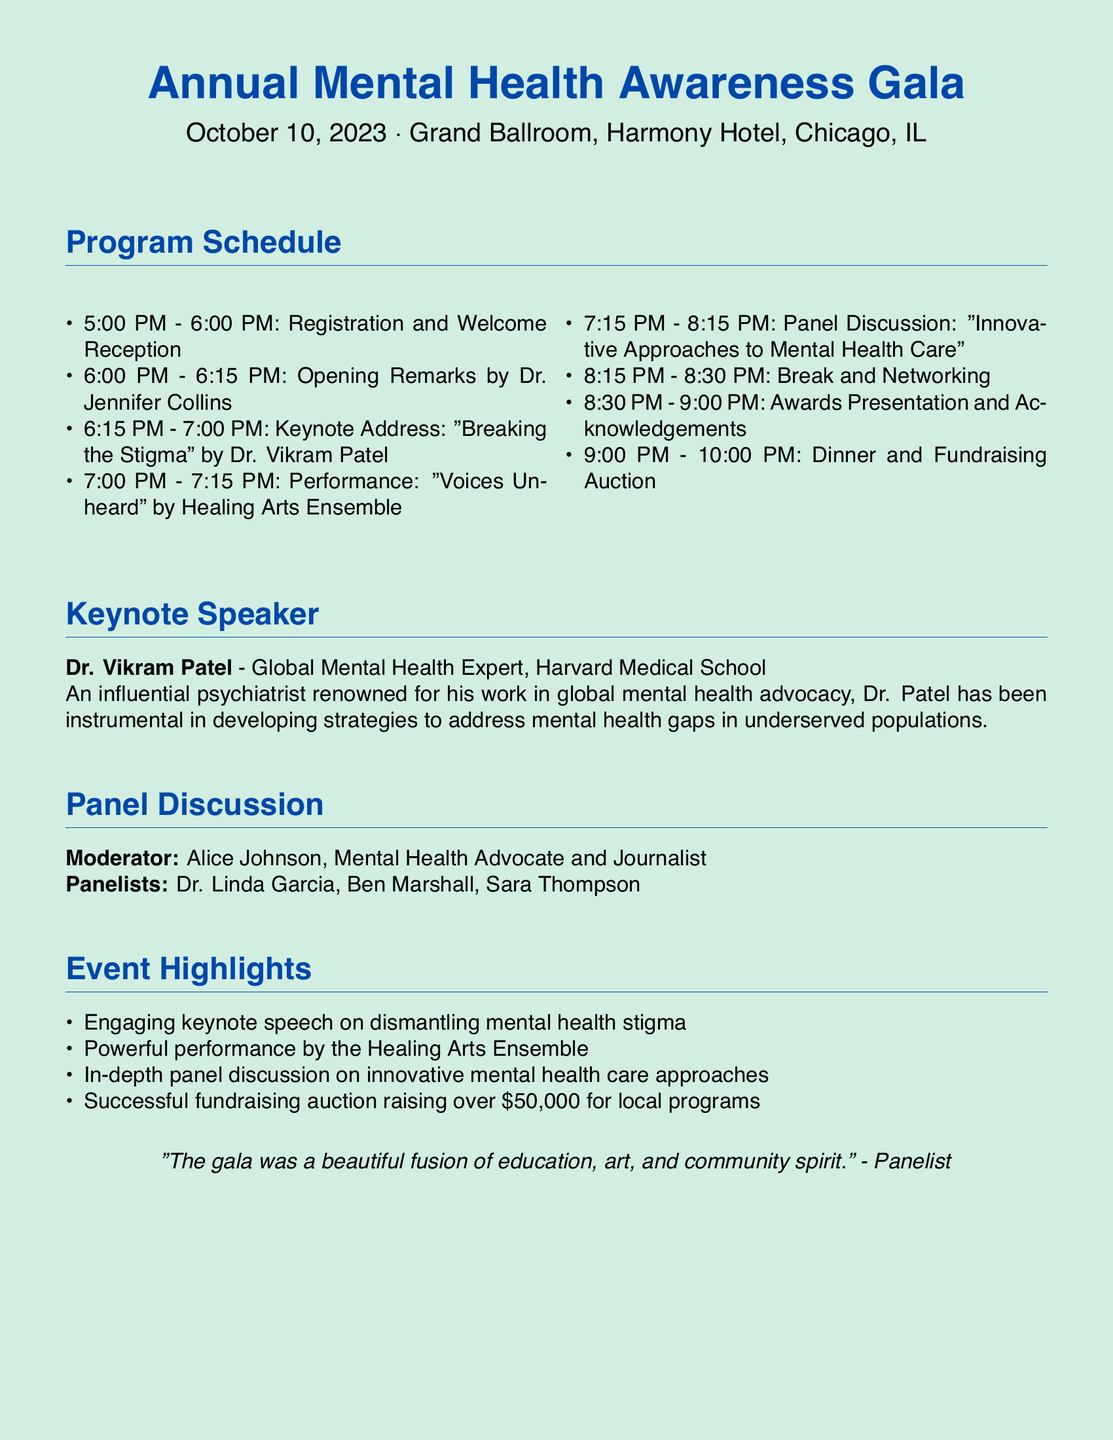What is the date of the Annual Mental Health Awareness Gala? The date is explicitly mentioned in the document as October 10, 2023.
Answer: October 10, 2023 Who is the keynote speaker at the event? The keynote speaker is listed as Dr. Vikram Patel in the document.
Answer: Dr. Vikram Patel What time does the registration start? The document states that registration begins at 5:00 PM.
Answer: 5:00 PM How long is the keynote address? The duration of the keynote address is specified as 45 minutes, from 6:15 PM to 7:00 PM.
Answer: 45 minutes What was the amount raised during the fundraising auction? The document mentions that the fundraising auction raised over $50,000.
Answer: over $50,000 Who moderated the panel discussion? The moderator of the panel discussion is identified as Alice Johnson in the document.
Answer: Alice Johnson What performance is scheduled after the keynote address? The performance scheduled is called "Voices Unheard" by Healing Arts Ensemble.
Answer: "Voices Unheard" Which room is the event held in? The Gala is stated to take place in the Grand Ballroom of Harmony Hotel.
Answer: Grand Ballroom, Harmony Hotel What theme is addressed in the keynote address? The theme of the keynote address is "Breaking the Stigma."
Answer: Breaking the Stigma 